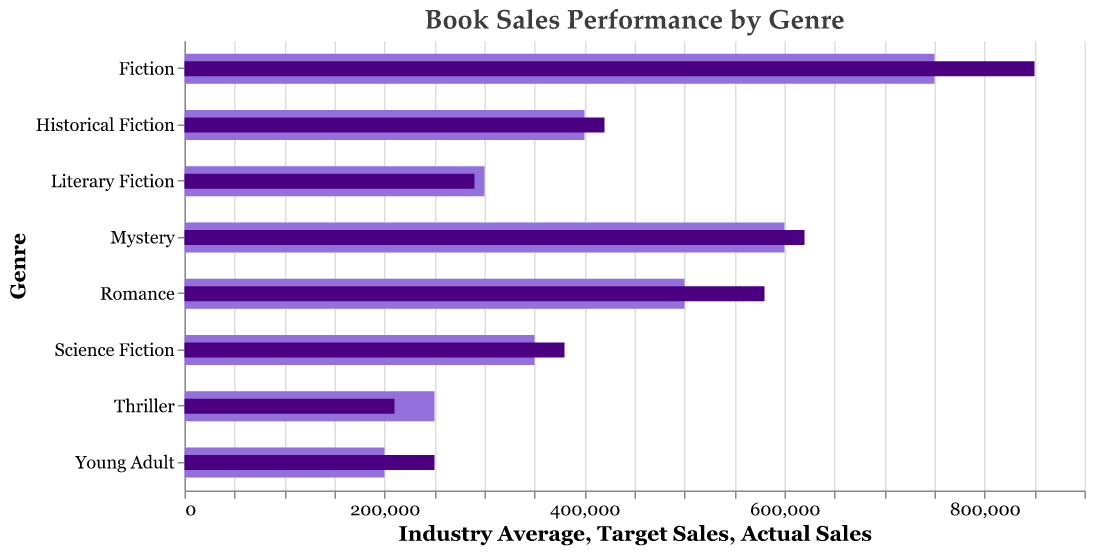What's the title of the figure? The title is displayed at the top center of the figure and reads "Book Sales Performance by Genre."
Answer: Book Sales Performance by Genre How many genres are displayed in the figure? The Y-axis lists the genres, and there are 8 distinct genre labels: Fiction, Mystery, Romance, Historical Fiction, Science Fiction, Literary Fiction, Young Adult, and Thriller.
Answer: 8 Which genre has the highest actual sales? By looking at the darkest bar (representing actual sales) that extends the farthest to the right, Fiction is the genre with the highest actual sales.
Answer: Fiction Did the Thriller genre meet its target sales? Compare the actual sales (darkest bar) of Thriller to its target sales (mid-tone bar). The actual sales bar is shorter than the target sales bar, indicating it did not meet the target.
Answer: No How much did Science Fiction exceed its industry average sales? Science Fiction's industry average is 250,000 units and its actual sales are 380,000 units. Subtract the industry average from the actual sales: 380,000 - 250,000.
Answer: 130,000 Which genre has the smallest difference between actual and target sales? Observe the bars for each genre and compare the gap between the actual sales bar (darkest) and the target sales bar (mid-tone). Historical Fiction has the smallest gap.
Answer: Historical Fiction Compare the actual sales of Mystery and Romance. Which is higher? By comparing the darkest bars for Mystery and Romance, Mystery's actual sales bar extends further to the right than Romance's bar.
Answer: Mystery What is the color used to represent actual sales? By observing the color legend mapping in the bars, the darkest color (dark purple) represents the actual sales.
Answer: Dark purple Which genre performed worse compared to its industry average in terms of actual sales minus industry average? Calculate the difference between actual sales and industry average for all genres. Literary Fiction's value is 290,000 - 200,000 = 90,000, which is less than the differences for other genres.
Answer: Literary Fiction Among the genres with actual sales higher than their target, which has the highest margin over the target? By comparing the actual sales (darkest) and target sales (mid-tone) bars of genres with actual sales surpassing their targets, Fiction has the highest margin. It exceeded its target by 850,000 - 750,000.
Answer: Fiction 